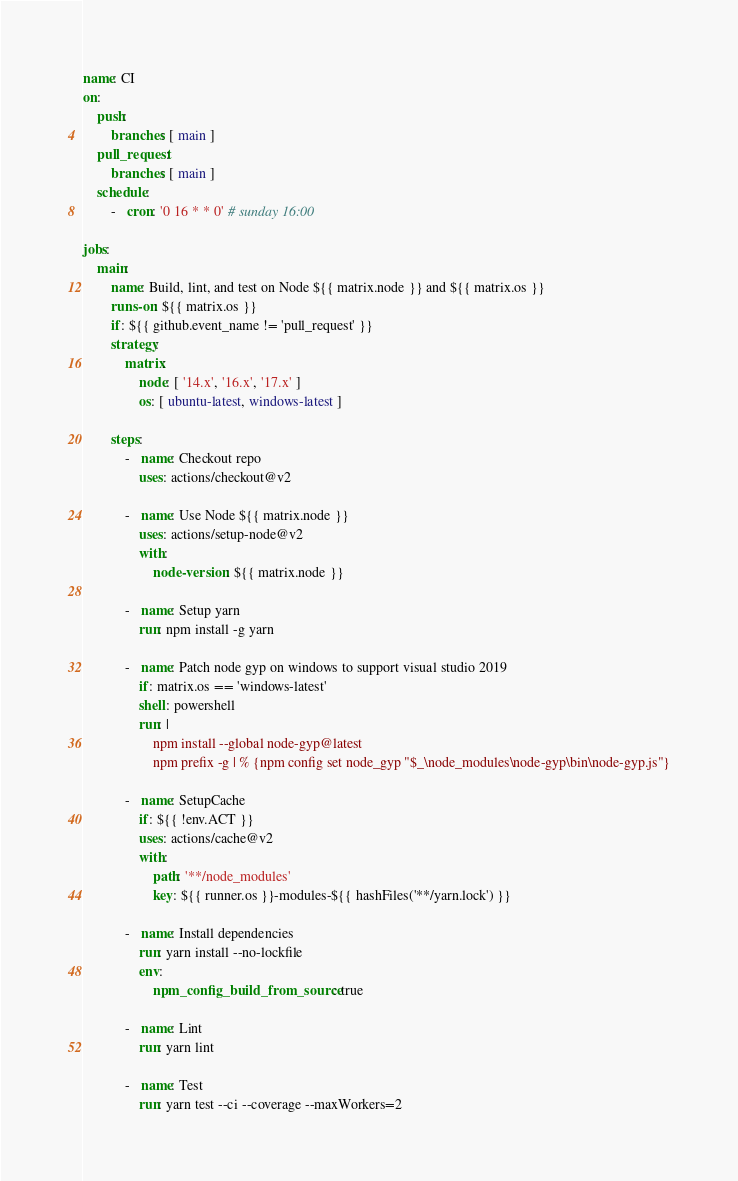Convert code to text. <code><loc_0><loc_0><loc_500><loc_500><_YAML_>name: CI
on:
    push:
        branches: [ main ]
    pull_request:
        branches: [ main ]
    schedule:
        -   cron: '0 16 * * 0' # sunday 16:00

jobs:
    main:
        name: Build, lint, and test on Node ${{ matrix.node }} and ${{ matrix.os }}
        runs-on: ${{ matrix.os }}
        if: ${{ github.event_name != 'pull_request' }}
        strategy:
            matrix:
                node: [ '14.x', '16.x', '17.x' ]
                os: [ ubuntu-latest, windows-latest ]

        steps:
            -   name: Checkout repo
                uses: actions/checkout@v2

            -   name: Use Node ${{ matrix.node }}
                uses: actions/setup-node@v2
                with:
                    node-version: ${{ matrix.node }}

            -   name: Setup yarn
                run: npm install -g yarn

            -   name: Patch node gyp on windows to support visual studio 2019
                if: matrix.os == 'windows-latest'
                shell: powershell
                run: |
                    npm install --global node-gyp@latest
                    npm prefix -g | % {npm config set node_gyp "$_\node_modules\node-gyp\bin\node-gyp.js"}

            -   name: SetupCache
                if: ${{ !env.ACT }}
                uses: actions/cache@v2
                with:
                    path: '**/node_modules'
                    key: ${{ runner.os }}-modules-${{ hashFiles('**/yarn.lock') }}

            -   name: Install dependencies
                run: yarn install --no-lockfile
                env:
                    npm_config_build_from_source: true

            -   name: Lint
                run: yarn lint

            -   name: Test
                run: yarn test --ci --coverage --maxWorkers=2
</code> 